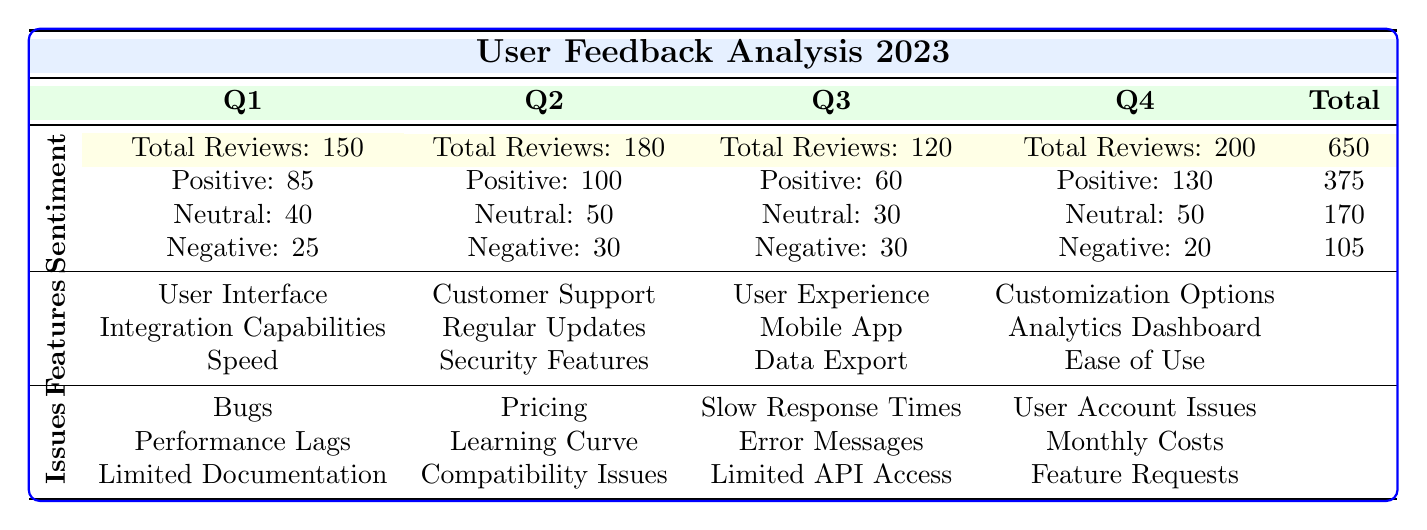What is the total number of reviews received in Q3? The table directly states that the Total Reviews for Q3 is 120.
Answer: 120 How many positive reviews were there in Q1? According to the table, the number of Positive reviews for Q1 is 85.
Answer: 85 Which quarter had the highest number of negative reviews? By comparing the Negative reviews across all quarters, Q1, Q2, and Q3 had 25, 30, and 30 respectively, while Q4 had 20. Q2 and Q3 tied for the highest with 30.
Answer: Q2 and Q3 What is the average number of total reviews received per quarter? The total number of reviews is the sum of reviews from all quarters, which is 150 + 180 + 120 + 200 = 650. There are 4 quarters, so the average is 650 / 4 = 162.5.
Answer: 162.5 Are there any common feedback issues that appeared in all four quarters? The Common Feedback issues listed do not show any repetition across the four quarters, as each quarter has distinct issues.
Answer: No Which quarter had the highest percentage of positive reviews out of total reviews? Q1 had Positive reviews of 85 out of 150, which gives us 56.67%. Q2 had 100 out of 180 (55.56%), Q3 had 60 out of 120 (50%), and Q4 had 130 out of 200 (65%). Q4 had the highest percentage among them.
Answer: Q4 What is the total number of neutral reviews across all quarters? To find the total neutral reviews, we add the Neutral values from each quarter: 40 + 50 + 30 + 50 = 170.
Answer: 170 Did any quarter experience an increase in the number of total reviews compared to the previous quarter? Comparing the reviews: Q1 (150) to Q2 (180): increase, Q2 (180) to Q3 (120): decrease, Q3 (120) to Q4 (200): increase. Yes, Q1 to Q2 and Q3 to Q4 experienced increases.
Answer: Yes What is the total count of common feedback features mentioned throughout the year? Summing the number of unique features across all quarters, Q1 (3), Q2 (3), Q3 (3), Q4 (3) leads to a total of 12 different instances, but no unique features were repeated, showing unique feedback across quarters.
Answer: 12 